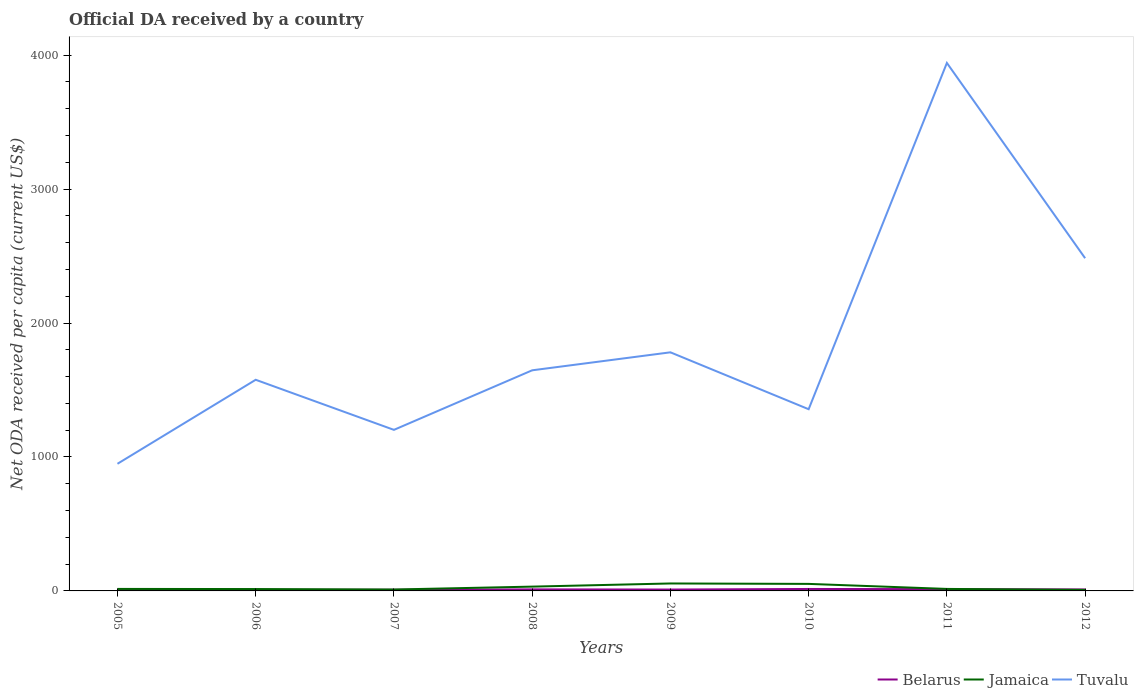How many different coloured lines are there?
Offer a very short reply. 3. Does the line corresponding to Tuvalu intersect with the line corresponding to Jamaica?
Give a very brief answer. No. Across all years, what is the maximum ODA received in in Belarus?
Your answer should be very brief. 5.98. In which year was the ODA received in in Jamaica maximum?
Your response must be concise. 2012. What is the total ODA received in in Belarus in the graph?
Ensure brevity in your answer.  -2.15. What is the difference between the highest and the second highest ODA received in in Belarus?
Provide a succinct answer. 8.57. How many years are there in the graph?
Your response must be concise. 8. What is the difference between two consecutive major ticks on the Y-axis?
Ensure brevity in your answer.  1000. Where does the legend appear in the graph?
Give a very brief answer. Bottom right. How many legend labels are there?
Offer a terse response. 3. What is the title of the graph?
Your answer should be compact. Official DA received by a country. Does "Isle of Man" appear as one of the legend labels in the graph?
Give a very brief answer. No. What is the label or title of the X-axis?
Provide a short and direct response. Years. What is the label or title of the Y-axis?
Offer a terse response. Net ODA received per capita (current US$). What is the Net ODA received per capita (current US$) in Belarus in 2005?
Keep it short and to the point. 5.98. What is the Net ODA received per capita (current US$) in Jamaica in 2005?
Your answer should be very brief. 14.98. What is the Net ODA received per capita (current US$) in Tuvalu in 2005?
Make the answer very short. 949.04. What is the Net ODA received per capita (current US$) in Belarus in 2006?
Your answer should be very brief. 7.97. What is the Net ODA received per capita (current US$) of Jamaica in 2006?
Your answer should be very brief. 14.02. What is the Net ODA received per capita (current US$) of Tuvalu in 2006?
Ensure brevity in your answer.  1576.24. What is the Net ODA received per capita (current US$) of Belarus in 2007?
Provide a short and direct response. 8.76. What is the Net ODA received per capita (current US$) in Jamaica in 2007?
Make the answer very short. 10.55. What is the Net ODA received per capita (current US$) in Tuvalu in 2007?
Your answer should be compact. 1202.38. What is the Net ODA received per capita (current US$) of Belarus in 2008?
Give a very brief answer. 11.59. What is the Net ODA received per capita (current US$) in Jamaica in 2008?
Your answer should be compact. 32.12. What is the Net ODA received per capita (current US$) of Tuvalu in 2008?
Provide a short and direct response. 1646.91. What is the Net ODA received per capita (current US$) in Belarus in 2009?
Your answer should be compact. 10.27. What is the Net ODA received per capita (current US$) in Jamaica in 2009?
Offer a very short reply. 55.68. What is the Net ODA received per capita (current US$) in Tuvalu in 2009?
Your response must be concise. 1781.2. What is the Net ODA received per capita (current US$) in Belarus in 2010?
Ensure brevity in your answer.  14.55. What is the Net ODA received per capita (current US$) of Jamaica in 2010?
Provide a short and direct response. 52.49. What is the Net ODA received per capita (current US$) in Tuvalu in 2010?
Give a very brief answer. 1356.47. What is the Net ODA received per capita (current US$) of Belarus in 2011?
Provide a succinct answer. 13.3. What is the Net ODA received per capita (current US$) in Jamaica in 2011?
Your response must be concise. 14.91. What is the Net ODA received per capita (current US$) of Tuvalu in 2011?
Keep it short and to the point. 3941.49. What is the Net ODA received per capita (current US$) in Belarus in 2012?
Your answer should be compact. 10.91. What is the Net ODA received per capita (current US$) of Jamaica in 2012?
Keep it short and to the point. 7.77. What is the Net ODA received per capita (current US$) in Tuvalu in 2012?
Give a very brief answer. 2483.77. Across all years, what is the maximum Net ODA received per capita (current US$) in Belarus?
Your answer should be compact. 14.55. Across all years, what is the maximum Net ODA received per capita (current US$) in Jamaica?
Your response must be concise. 55.68. Across all years, what is the maximum Net ODA received per capita (current US$) of Tuvalu?
Give a very brief answer. 3941.49. Across all years, what is the minimum Net ODA received per capita (current US$) in Belarus?
Give a very brief answer. 5.98. Across all years, what is the minimum Net ODA received per capita (current US$) of Jamaica?
Offer a very short reply. 7.77. Across all years, what is the minimum Net ODA received per capita (current US$) in Tuvalu?
Keep it short and to the point. 949.04. What is the total Net ODA received per capita (current US$) of Belarus in the graph?
Keep it short and to the point. 83.34. What is the total Net ODA received per capita (current US$) of Jamaica in the graph?
Ensure brevity in your answer.  202.5. What is the total Net ODA received per capita (current US$) in Tuvalu in the graph?
Give a very brief answer. 1.49e+04. What is the difference between the Net ODA received per capita (current US$) in Belarus in 2005 and that in 2006?
Keep it short and to the point. -1.98. What is the difference between the Net ODA received per capita (current US$) in Jamaica in 2005 and that in 2006?
Provide a short and direct response. 0.96. What is the difference between the Net ODA received per capita (current US$) of Tuvalu in 2005 and that in 2006?
Keep it short and to the point. -627.2. What is the difference between the Net ODA received per capita (current US$) in Belarus in 2005 and that in 2007?
Your answer should be very brief. -2.78. What is the difference between the Net ODA received per capita (current US$) of Jamaica in 2005 and that in 2007?
Your answer should be compact. 4.43. What is the difference between the Net ODA received per capita (current US$) of Tuvalu in 2005 and that in 2007?
Your response must be concise. -253.34. What is the difference between the Net ODA received per capita (current US$) of Belarus in 2005 and that in 2008?
Provide a short and direct response. -5.61. What is the difference between the Net ODA received per capita (current US$) in Jamaica in 2005 and that in 2008?
Offer a very short reply. -17.14. What is the difference between the Net ODA received per capita (current US$) of Tuvalu in 2005 and that in 2008?
Ensure brevity in your answer.  -697.87. What is the difference between the Net ODA received per capita (current US$) of Belarus in 2005 and that in 2009?
Offer a very short reply. -4.29. What is the difference between the Net ODA received per capita (current US$) in Jamaica in 2005 and that in 2009?
Your answer should be very brief. -40.7. What is the difference between the Net ODA received per capita (current US$) in Tuvalu in 2005 and that in 2009?
Make the answer very short. -832.16. What is the difference between the Net ODA received per capita (current US$) in Belarus in 2005 and that in 2010?
Keep it short and to the point. -8.57. What is the difference between the Net ODA received per capita (current US$) in Jamaica in 2005 and that in 2010?
Offer a terse response. -37.51. What is the difference between the Net ODA received per capita (current US$) in Tuvalu in 2005 and that in 2010?
Ensure brevity in your answer.  -407.43. What is the difference between the Net ODA received per capita (current US$) in Belarus in 2005 and that in 2011?
Offer a very short reply. -7.32. What is the difference between the Net ODA received per capita (current US$) of Jamaica in 2005 and that in 2011?
Your response must be concise. 0.07. What is the difference between the Net ODA received per capita (current US$) of Tuvalu in 2005 and that in 2011?
Make the answer very short. -2992.45. What is the difference between the Net ODA received per capita (current US$) of Belarus in 2005 and that in 2012?
Provide a succinct answer. -4.93. What is the difference between the Net ODA received per capita (current US$) of Jamaica in 2005 and that in 2012?
Make the answer very short. 7.2. What is the difference between the Net ODA received per capita (current US$) in Tuvalu in 2005 and that in 2012?
Offer a very short reply. -1534.73. What is the difference between the Net ODA received per capita (current US$) in Belarus in 2006 and that in 2007?
Make the answer very short. -0.79. What is the difference between the Net ODA received per capita (current US$) in Jamaica in 2006 and that in 2007?
Your answer should be compact. 3.47. What is the difference between the Net ODA received per capita (current US$) of Tuvalu in 2006 and that in 2007?
Ensure brevity in your answer.  373.87. What is the difference between the Net ODA received per capita (current US$) in Belarus in 2006 and that in 2008?
Provide a short and direct response. -3.62. What is the difference between the Net ODA received per capita (current US$) in Jamaica in 2006 and that in 2008?
Keep it short and to the point. -18.1. What is the difference between the Net ODA received per capita (current US$) of Tuvalu in 2006 and that in 2008?
Make the answer very short. -70.67. What is the difference between the Net ODA received per capita (current US$) of Belarus in 2006 and that in 2009?
Your response must be concise. -2.3. What is the difference between the Net ODA received per capita (current US$) in Jamaica in 2006 and that in 2009?
Offer a terse response. -41.66. What is the difference between the Net ODA received per capita (current US$) of Tuvalu in 2006 and that in 2009?
Your answer should be compact. -204.96. What is the difference between the Net ODA received per capita (current US$) of Belarus in 2006 and that in 2010?
Give a very brief answer. -6.59. What is the difference between the Net ODA received per capita (current US$) of Jamaica in 2006 and that in 2010?
Offer a very short reply. -38.47. What is the difference between the Net ODA received per capita (current US$) in Tuvalu in 2006 and that in 2010?
Give a very brief answer. 219.78. What is the difference between the Net ODA received per capita (current US$) of Belarus in 2006 and that in 2011?
Keep it short and to the point. -5.33. What is the difference between the Net ODA received per capita (current US$) in Jamaica in 2006 and that in 2011?
Offer a terse response. -0.89. What is the difference between the Net ODA received per capita (current US$) in Tuvalu in 2006 and that in 2011?
Provide a short and direct response. -2365.24. What is the difference between the Net ODA received per capita (current US$) in Belarus in 2006 and that in 2012?
Give a very brief answer. -2.94. What is the difference between the Net ODA received per capita (current US$) in Jamaica in 2006 and that in 2012?
Provide a short and direct response. 6.24. What is the difference between the Net ODA received per capita (current US$) in Tuvalu in 2006 and that in 2012?
Provide a succinct answer. -907.53. What is the difference between the Net ODA received per capita (current US$) of Belarus in 2007 and that in 2008?
Ensure brevity in your answer.  -2.83. What is the difference between the Net ODA received per capita (current US$) of Jamaica in 2007 and that in 2008?
Offer a terse response. -21.57. What is the difference between the Net ODA received per capita (current US$) of Tuvalu in 2007 and that in 2008?
Provide a short and direct response. -444.54. What is the difference between the Net ODA received per capita (current US$) in Belarus in 2007 and that in 2009?
Keep it short and to the point. -1.51. What is the difference between the Net ODA received per capita (current US$) in Jamaica in 2007 and that in 2009?
Your answer should be compact. -45.13. What is the difference between the Net ODA received per capita (current US$) in Tuvalu in 2007 and that in 2009?
Give a very brief answer. -578.82. What is the difference between the Net ODA received per capita (current US$) in Belarus in 2007 and that in 2010?
Ensure brevity in your answer.  -5.79. What is the difference between the Net ODA received per capita (current US$) of Jamaica in 2007 and that in 2010?
Ensure brevity in your answer.  -41.94. What is the difference between the Net ODA received per capita (current US$) in Tuvalu in 2007 and that in 2010?
Your answer should be very brief. -154.09. What is the difference between the Net ODA received per capita (current US$) of Belarus in 2007 and that in 2011?
Your response must be concise. -4.54. What is the difference between the Net ODA received per capita (current US$) in Jamaica in 2007 and that in 2011?
Give a very brief answer. -4.36. What is the difference between the Net ODA received per capita (current US$) in Tuvalu in 2007 and that in 2011?
Provide a succinct answer. -2739.11. What is the difference between the Net ODA received per capita (current US$) in Belarus in 2007 and that in 2012?
Make the answer very short. -2.15. What is the difference between the Net ODA received per capita (current US$) of Jamaica in 2007 and that in 2012?
Your answer should be very brief. 2.77. What is the difference between the Net ODA received per capita (current US$) in Tuvalu in 2007 and that in 2012?
Your answer should be very brief. -1281.4. What is the difference between the Net ODA received per capita (current US$) of Belarus in 2008 and that in 2009?
Your answer should be compact. 1.32. What is the difference between the Net ODA received per capita (current US$) of Jamaica in 2008 and that in 2009?
Your response must be concise. -23.56. What is the difference between the Net ODA received per capita (current US$) of Tuvalu in 2008 and that in 2009?
Your answer should be very brief. -134.28. What is the difference between the Net ODA received per capita (current US$) in Belarus in 2008 and that in 2010?
Provide a succinct answer. -2.96. What is the difference between the Net ODA received per capita (current US$) in Jamaica in 2008 and that in 2010?
Make the answer very short. -20.37. What is the difference between the Net ODA received per capita (current US$) in Tuvalu in 2008 and that in 2010?
Your response must be concise. 290.45. What is the difference between the Net ODA received per capita (current US$) of Belarus in 2008 and that in 2011?
Give a very brief answer. -1.71. What is the difference between the Net ODA received per capita (current US$) of Jamaica in 2008 and that in 2011?
Make the answer very short. 17.21. What is the difference between the Net ODA received per capita (current US$) of Tuvalu in 2008 and that in 2011?
Provide a short and direct response. -2294.57. What is the difference between the Net ODA received per capita (current US$) in Belarus in 2008 and that in 2012?
Your answer should be very brief. 0.68. What is the difference between the Net ODA received per capita (current US$) of Jamaica in 2008 and that in 2012?
Your answer should be very brief. 24.34. What is the difference between the Net ODA received per capita (current US$) in Tuvalu in 2008 and that in 2012?
Give a very brief answer. -836.86. What is the difference between the Net ODA received per capita (current US$) in Belarus in 2009 and that in 2010?
Your answer should be compact. -4.28. What is the difference between the Net ODA received per capita (current US$) in Jamaica in 2009 and that in 2010?
Provide a succinct answer. 3.19. What is the difference between the Net ODA received per capita (current US$) of Tuvalu in 2009 and that in 2010?
Offer a terse response. 424.73. What is the difference between the Net ODA received per capita (current US$) of Belarus in 2009 and that in 2011?
Ensure brevity in your answer.  -3.03. What is the difference between the Net ODA received per capita (current US$) of Jamaica in 2009 and that in 2011?
Keep it short and to the point. 40.77. What is the difference between the Net ODA received per capita (current US$) of Tuvalu in 2009 and that in 2011?
Your response must be concise. -2160.29. What is the difference between the Net ODA received per capita (current US$) in Belarus in 2009 and that in 2012?
Offer a very short reply. -0.64. What is the difference between the Net ODA received per capita (current US$) in Jamaica in 2009 and that in 2012?
Provide a succinct answer. 47.91. What is the difference between the Net ODA received per capita (current US$) in Tuvalu in 2009 and that in 2012?
Provide a short and direct response. -702.57. What is the difference between the Net ODA received per capita (current US$) of Belarus in 2010 and that in 2011?
Your response must be concise. 1.25. What is the difference between the Net ODA received per capita (current US$) in Jamaica in 2010 and that in 2011?
Keep it short and to the point. 37.58. What is the difference between the Net ODA received per capita (current US$) in Tuvalu in 2010 and that in 2011?
Your answer should be very brief. -2585.02. What is the difference between the Net ODA received per capita (current US$) of Belarus in 2010 and that in 2012?
Ensure brevity in your answer.  3.64. What is the difference between the Net ODA received per capita (current US$) of Jamaica in 2010 and that in 2012?
Offer a very short reply. 44.71. What is the difference between the Net ODA received per capita (current US$) in Tuvalu in 2010 and that in 2012?
Make the answer very short. -1127.31. What is the difference between the Net ODA received per capita (current US$) of Belarus in 2011 and that in 2012?
Provide a short and direct response. 2.39. What is the difference between the Net ODA received per capita (current US$) of Jamaica in 2011 and that in 2012?
Offer a terse response. 7.13. What is the difference between the Net ODA received per capita (current US$) of Tuvalu in 2011 and that in 2012?
Offer a terse response. 1457.71. What is the difference between the Net ODA received per capita (current US$) in Belarus in 2005 and the Net ODA received per capita (current US$) in Jamaica in 2006?
Your response must be concise. -8.04. What is the difference between the Net ODA received per capita (current US$) in Belarus in 2005 and the Net ODA received per capita (current US$) in Tuvalu in 2006?
Keep it short and to the point. -1570.26. What is the difference between the Net ODA received per capita (current US$) in Jamaica in 2005 and the Net ODA received per capita (current US$) in Tuvalu in 2006?
Give a very brief answer. -1561.27. What is the difference between the Net ODA received per capita (current US$) in Belarus in 2005 and the Net ODA received per capita (current US$) in Jamaica in 2007?
Offer a terse response. -4.56. What is the difference between the Net ODA received per capita (current US$) of Belarus in 2005 and the Net ODA received per capita (current US$) of Tuvalu in 2007?
Offer a very short reply. -1196.39. What is the difference between the Net ODA received per capita (current US$) of Jamaica in 2005 and the Net ODA received per capita (current US$) of Tuvalu in 2007?
Offer a terse response. -1187.4. What is the difference between the Net ODA received per capita (current US$) in Belarus in 2005 and the Net ODA received per capita (current US$) in Jamaica in 2008?
Your response must be concise. -26.13. What is the difference between the Net ODA received per capita (current US$) of Belarus in 2005 and the Net ODA received per capita (current US$) of Tuvalu in 2008?
Keep it short and to the point. -1640.93. What is the difference between the Net ODA received per capita (current US$) of Jamaica in 2005 and the Net ODA received per capita (current US$) of Tuvalu in 2008?
Provide a short and direct response. -1631.94. What is the difference between the Net ODA received per capita (current US$) in Belarus in 2005 and the Net ODA received per capita (current US$) in Jamaica in 2009?
Give a very brief answer. -49.7. What is the difference between the Net ODA received per capita (current US$) of Belarus in 2005 and the Net ODA received per capita (current US$) of Tuvalu in 2009?
Give a very brief answer. -1775.22. What is the difference between the Net ODA received per capita (current US$) of Jamaica in 2005 and the Net ODA received per capita (current US$) of Tuvalu in 2009?
Your answer should be compact. -1766.22. What is the difference between the Net ODA received per capita (current US$) in Belarus in 2005 and the Net ODA received per capita (current US$) in Jamaica in 2010?
Your response must be concise. -46.5. What is the difference between the Net ODA received per capita (current US$) of Belarus in 2005 and the Net ODA received per capita (current US$) of Tuvalu in 2010?
Ensure brevity in your answer.  -1350.48. What is the difference between the Net ODA received per capita (current US$) in Jamaica in 2005 and the Net ODA received per capita (current US$) in Tuvalu in 2010?
Your answer should be very brief. -1341.49. What is the difference between the Net ODA received per capita (current US$) of Belarus in 2005 and the Net ODA received per capita (current US$) of Jamaica in 2011?
Make the answer very short. -8.93. What is the difference between the Net ODA received per capita (current US$) in Belarus in 2005 and the Net ODA received per capita (current US$) in Tuvalu in 2011?
Your answer should be compact. -3935.5. What is the difference between the Net ODA received per capita (current US$) of Jamaica in 2005 and the Net ODA received per capita (current US$) of Tuvalu in 2011?
Your response must be concise. -3926.51. What is the difference between the Net ODA received per capita (current US$) of Belarus in 2005 and the Net ODA received per capita (current US$) of Jamaica in 2012?
Make the answer very short. -1.79. What is the difference between the Net ODA received per capita (current US$) in Belarus in 2005 and the Net ODA received per capita (current US$) in Tuvalu in 2012?
Keep it short and to the point. -2477.79. What is the difference between the Net ODA received per capita (current US$) of Jamaica in 2005 and the Net ODA received per capita (current US$) of Tuvalu in 2012?
Offer a terse response. -2468.8. What is the difference between the Net ODA received per capita (current US$) of Belarus in 2006 and the Net ODA received per capita (current US$) of Jamaica in 2007?
Give a very brief answer. -2.58. What is the difference between the Net ODA received per capita (current US$) of Belarus in 2006 and the Net ODA received per capita (current US$) of Tuvalu in 2007?
Provide a succinct answer. -1194.41. What is the difference between the Net ODA received per capita (current US$) in Jamaica in 2006 and the Net ODA received per capita (current US$) in Tuvalu in 2007?
Offer a very short reply. -1188.36. What is the difference between the Net ODA received per capita (current US$) of Belarus in 2006 and the Net ODA received per capita (current US$) of Jamaica in 2008?
Make the answer very short. -24.15. What is the difference between the Net ODA received per capita (current US$) of Belarus in 2006 and the Net ODA received per capita (current US$) of Tuvalu in 2008?
Ensure brevity in your answer.  -1638.95. What is the difference between the Net ODA received per capita (current US$) in Jamaica in 2006 and the Net ODA received per capita (current US$) in Tuvalu in 2008?
Make the answer very short. -1632.9. What is the difference between the Net ODA received per capita (current US$) of Belarus in 2006 and the Net ODA received per capita (current US$) of Jamaica in 2009?
Your response must be concise. -47.71. What is the difference between the Net ODA received per capita (current US$) of Belarus in 2006 and the Net ODA received per capita (current US$) of Tuvalu in 2009?
Provide a short and direct response. -1773.23. What is the difference between the Net ODA received per capita (current US$) in Jamaica in 2006 and the Net ODA received per capita (current US$) in Tuvalu in 2009?
Offer a very short reply. -1767.18. What is the difference between the Net ODA received per capita (current US$) of Belarus in 2006 and the Net ODA received per capita (current US$) of Jamaica in 2010?
Your answer should be compact. -44.52. What is the difference between the Net ODA received per capita (current US$) in Belarus in 2006 and the Net ODA received per capita (current US$) in Tuvalu in 2010?
Your answer should be very brief. -1348.5. What is the difference between the Net ODA received per capita (current US$) of Jamaica in 2006 and the Net ODA received per capita (current US$) of Tuvalu in 2010?
Keep it short and to the point. -1342.45. What is the difference between the Net ODA received per capita (current US$) of Belarus in 2006 and the Net ODA received per capita (current US$) of Jamaica in 2011?
Give a very brief answer. -6.94. What is the difference between the Net ODA received per capita (current US$) in Belarus in 2006 and the Net ODA received per capita (current US$) in Tuvalu in 2011?
Provide a short and direct response. -3933.52. What is the difference between the Net ODA received per capita (current US$) of Jamaica in 2006 and the Net ODA received per capita (current US$) of Tuvalu in 2011?
Offer a very short reply. -3927.47. What is the difference between the Net ODA received per capita (current US$) in Belarus in 2006 and the Net ODA received per capita (current US$) in Jamaica in 2012?
Make the answer very short. 0.19. What is the difference between the Net ODA received per capita (current US$) of Belarus in 2006 and the Net ODA received per capita (current US$) of Tuvalu in 2012?
Give a very brief answer. -2475.81. What is the difference between the Net ODA received per capita (current US$) of Jamaica in 2006 and the Net ODA received per capita (current US$) of Tuvalu in 2012?
Provide a succinct answer. -2469.75. What is the difference between the Net ODA received per capita (current US$) of Belarus in 2007 and the Net ODA received per capita (current US$) of Jamaica in 2008?
Ensure brevity in your answer.  -23.35. What is the difference between the Net ODA received per capita (current US$) in Belarus in 2007 and the Net ODA received per capita (current US$) in Tuvalu in 2008?
Offer a very short reply. -1638.15. What is the difference between the Net ODA received per capita (current US$) in Jamaica in 2007 and the Net ODA received per capita (current US$) in Tuvalu in 2008?
Keep it short and to the point. -1636.37. What is the difference between the Net ODA received per capita (current US$) of Belarus in 2007 and the Net ODA received per capita (current US$) of Jamaica in 2009?
Your answer should be very brief. -46.92. What is the difference between the Net ODA received per capita (current US$) in Belarus in 2007 and the Net ODA received per capita (current US$) in Tuvalu in 2009?
Give a very brief answer. -1772.44. What is the difference between the Net ODA received per capita (current US$) of Jamaica in 2007 and the Net ODA received per capita (current US$) of Tuvalu in 2009?
Offer a very short reply. -1770.65. What is the difference between the Net ODA received per capita (current US$) of Belarus in 2007 and the Net ODA received per capita (current US$) of Jamaica in 2010?
Offer a terse response. -43.72. What is the difference between the Net ODA received per capita (current US$) in Belarus in 2007 and the Net ODA received per capita (current US$) in Tuvalu in 2010?
Keep it short and to the point. -1347.71. What is the difference between the Net ODA received per capita (current US$) of Jamaica in 2007 and the Net ODA received per capita (current US$) of Tuvalu in 2010?
Provide a short and direct response. -1345.92. What is the difference between the Net ODA received per capita (current US$) in Belarus in 2007 and the Net ODA received per capita (current US$) in Jamaica in 2011?
Offer a terse response. -6.15. What is the difference between the Net ODA received per capita (current US$) of Belarus in 2007 and the Net ODA received per capita (current US$) of Tuvalu in 2011?
Give a very brief answer. -3932.73. What is the difference between the Net ODA received per capita (current US$) of Jamaica in 2007 and the Net ODA received per capita (current US$) of Tuvalu in 2011?
Ensure brevity in your answer.  -3930.94. What is the difference between the Net ODA received per capita (current US$) of Belarus in 2007 and the Net ODA received per capita (current US$) of Jamaica in 2012?
Keep it short and to the point. 0.99. What is the difference between the Net ODA received per capita (current US$) in Belarus in 2007 and the Net ODA received per capita (current US$) in Tuvalu in 2012?
Your answer should be compact. -2475.01. What is the difference between the Net ODA received per capita (current US$) in Jamaica in 2007 and the Net ODA received per capita (current US$) in Tuvalu in 2012?
Your answer should be very brief. -2473.23. What is the difference between the Net ODA received per capita (current US$) of Belarus in 2008 and the Net ODA received per capita (current US$) of Jamaica in 2009?
Provide a succinct answer. -44.09. What is the difference between the Net ODA received per capita (current US$) in Belarus in 2008 and the Net ODA received per capita (current US$) in Tuvalu in 2009?
Your answer should be very brief. -1769.61. What is the difference between the Net ODA received per capita (current US$) of Jamaica in 2008 and the Net ODA received per capita (current US$) of Tuvalu in 2009?
Provide a succinct answer. -1749.08. What is the difference between the Net ODA received per capita (current US$) of Belarus in 2008 and the Net ODA received per capita (current US$) of Jamaica in 2010?
Offer a very short reply. -40.9. What is the difference between the Net ODA received per capita (current US$) in Belarus in 2008 and the Net ODA received per capita (current US$) in Tuvalu in 2010?
Ensure brevity in your answer.  -1344.88. What is the difference between the Net ODA received per capita (current US$) in Jamaica in 2008 and the Net ODA received per capita (current US$) in Tuvalu in 2010?
Your answer should be compact. -1324.35. What is the difference between the Net ODA received per capita (current US$) of Belarus in 2008 and the Net ODA received per capita (current US$) of Jamaica in 2011?
Your answer should be very brief. -3.32. What is the difference between the Net ODA received per capita (current US$) of Belarus in 2008 and the Net ODA received per capita (current US$) of Tuvalu in 2011?
Your answer should be very brief. -3929.9. What is the difference between the Net ODA received per capita (current US$) of Jamaica in 2008 and the Net ODA received per capita (current US$) of Tuvalu in 2011?
Keep it short and to the point. -3909.37. What is the difference between the Net ODA received per capita (current US$) of Belarus in 2008 and the Net ODA received per capita (current US$) of Jamaica in 2012?
Give a very brief answer. 3.82. What is the difference between the Net ODA received per capita (current US$) in Belarus in 2008 and the Net ODA received per capita (current US$) in Tuvalu in 2012?
Make the answer very short. -2472.18. What is the difference between the Net ODA received per capita (current US$) in Jamaica in 2008 and the Net ODA received per capita (current US$) in Tuvalu in 2012?
Give a very brief answer. -2451.66. What is the difference between the Net ODA received per capita (current US$) in Belarus in 2009 and the Net ODA received per capita (current US$) in Jamaica in 2010?
Offer a very short reply. -42.21. What is the difference between the Net ODA received per capita (current US$) of Belarus in 2009 and the Net ODA received per capita (current US$) of Tuvalu in 2010?
Make the answer very short. -1346.19. What is the difference between the Net ODA received per capita (current US$) in Jamaica in 2009 and the Net ODA received per capita (current US$) in Tuvalu in 2010?
Offer a very short reply. -1300.79. What is the difference between the Net ODA received per capita (current US$) in Belarus in 2009 and the Net ODA received per capita (current US$) in Jamaica in 2011?
Give a very brief answer. -4.64. What is the difference between the Net ODA received per capita (current US$) of Belarus in 2009 and the Net ODA received per capita (current US$) of Tuvalu in 2011?
Keep it short and to the point. -3931.21. What is the difference between the Net ODA received per capita (current US$) of Jamaica in 2009 and the Net ODA received per capita (current US$) of Tuvalu in 2011?
Your response must be concise. -3885.81. What is the difference between the Net ODA received per capita (current US$) of Belarus in 2009 and the Net ODA received per capita (current US$) of Jamaica in 2012?
Provide a succinct answer. 2.5. What is the difference between the Net ODA received per capita (current US$) in Belarus in 2009 and the Net ODA received per capita (current US$) in Tuvalu in 2012?
Keep it short and to the point. -2473.5. What is the difference between the Net ODA received per capita (current US$) in Jamaica in 2009 and the Net ODA received per capita (current US$) in Tuvalu in 2012?
Ensure brevity in your answer.  -2428.09. What is the difference between the Net ODA received per capita (current US$) in Belarus in 2010 and the Net ODA received per capita (current US$) in Jamaica in 2011?
Your answer should be very brief. -0.36. What is the difference between the Net ODA received per capita (current US$) of Belarus in 2010 and the Net ODA received per capita (current US$) of Tuvalu in 2011?
Your answer should be very brief. -3926.93. What is the difference between the Net ODA received per capita (current US$) of Jamaica in 2010 and the Net ODA received per capita (current US$) of Tuvalu in 2011?
Provide a succinct answer. -3889. What is the difference between the Net ODA received per capita (current US$) in Belarus in 2010 and the Net ODA received per capita (current US$) in Jamaica in 2012?
Give a very brief answer. 6.78. What is the difference between the Net ODA received per capita (current US$) in Belarus in 2010 and the Net ODA received per capita (current US$) in Tuvalu in 2012?
Offer a terse response. -2469.22. What is the difference between the Net ODA received per capita (current US$) of Jamaica in 2010 and the Net ODA received per capita (current US$) of Tuvalu in 2012?
Your answer should be very brief. -2431.29. What is the difference between the Net ODA received per capita (current US$) in Belarus in 2011 and the Net ODA received per capita (current US$) in Jamaica in 2012?
Your answer should be compact. 5.53. What is the difference between the Net ODA received per capita (current US$) of Belarus in 2011 and the Net ODA received per capita (current US$) of Tuvalu in 2012?
Offer a terse response. -2470.47. What is the difference between the Net ODA received per capita (current US$) of Jamaica in 2011 and the Net ODA received per capita (current US$) of Tuvalu in 2012?
Offer a terse response. -2468.86. What is the average Net ODA received per capita (current US$) in Belarus per year?
Your response must be concise. 10.42. What is the average Net ODA received per capita (current US$) in Jamaica per year?
Your answer should be very brief. 25.31. What is the average Net ODA received per capita (current US$) of Tuvalu per year?
Provide a short and direct response. 1867.19. In the year 2005, what is the difference between the Net ODA received per capita (current US$) of Belarus and Net ODA received per capita (current US$) of Jamaica?
Provide a succinct answer. -8.99. In the year 2005, what is the difference between the Net ODA received per capita (current US$) in Belarus and Net ODA received per capita (current US$) in Tuvalu?
Provide a succinct answer. -943.06. In the year 2005, what is the difference between the Net ODA received per capita (current US$) in Jamaica and Net ODA received per capita (current US$) in Tuvalu?
Your response must be concise. -934.06. In the year 2006, what is the difference between the Net ODA received per capita (current US$) of Belarus and Net ODA received per capita (current US$) of Jamaica?
Give a very brief answer. -6.05. In the year 2006, what is the difference between the Net ODA received per capita (current US$) in Belarus and Net ODA received per capita (current US$) in Tuvalu?
Provide a succinct answer. -1568.28. In the year 2006, what is the difference between the Net ODA received per capita (current US$) in Jamaica and Net ODA received per capita (current US$) in Tuvalu?
Your response must be concise. -1562.23. In the year 2007, what is the difference between the Net ODA received per capita (current US$) of Belarus and Net ODA received per capita (current US$) of Jamaica?
Provide a short and direct response. -1.78. In the year 2007, what is the difference between the Net ODA received per capita (current US$) in Belarus and Net ODA received per capita (current US$) in Tuvalu?
Provide a succinct answer. -1193.61. In the year 2007, what is the difference between the Net ODA received per capita (current US$) of Jamaica and Net ODA received per capita (current US$) of Tuvalu?
Give a very brief answer. -1191.83. In the year 2008, what is the difference between the Net ODA received per capita (current US$) of Belarus and Net ODA received per capita (current US$) of Jamaica?
Provide a succinct answer. -20.53. In the year 2008, what is the difference between the Net ODA received per capita (current US$) of Belarus and Net ODA received per capita (current US$) of Tuvalu?
Keep it short and to the point. -1635.33. In the year 2008, what is the difference between the Net ODA received per capita (current US$) in Jamaica and Net ODA received per capita (current US$) in Tuvalu?
Your answer should be very brief. -1614.8. In the year 2009, what is the difference between the Net ODA received per capita (current US$) of Belarus and Net ODA received per capita (current US$) of Jamaica?
Keep it short and to the point. -45.41. In the year 2009, what is the difference between the Net ODA received per capita (current US$) of Belarus and Net ODA received per capita (current US$) of Tuvalu?
Provide a succinct answer. -1770.93. In the year 2009, what is the difference between the Net ODA received per capita (current US$) of Jamaica and Net ODA received per capita (current US$) of Tuvalu?
Your answer should be very brief. -1725.52. In the year 2010, what is the difference between the Net ODA received per capita (current US$) in Belarus and Net ODA received per capita (current US$) in Jamaica?
Your answer should be very brief. -37.93. In the year 2010, what is the difference between the Net ODA received per capita (current US$) of Belarus and Net ODA received per capita (current US$) of Tuvalu?
Ensure brevity in your answer.  -1341.91. In the year 2010, what is the difference between the Net ODA received per capita (current US$) in Jamaica and Net ODA received per capita (current US$) in Tuvalu?
Provide a short and direct response. -1303.98. In the year 2011, what is the difference between the Net ODA received per capita (current US$) of Belarus and Net ODA received per capita (current US$) of Jamaica?
Offer a very short reply. -1.61. In the year 2011, what is the difference between the Net ODA received per capita (current US$) in Belarus and Net ODA received per capita (current US$) in Tuvalu?
Keep it short and to the point. -3928.19. In the year 2011, what is the difference between the Net ODA received per capita (current US$) in Jamaica and Net ODA received per capita (current US$) in Tuvalu?
Keep it short and to the point. -3926.58. In the year 2012, what is the difference between the Net ODA received per capita (current US$) in Belarus and Net ODA received per capita (current US$) in Jamaica?
Provide a succinct answer. 3.14. In the year 2012, what is the difference between the Net ODA received per capita (current US$) of Belarus and Net ODA received per capita (current US$) of Tuvalu?
Your response must be concise. -2472.86. In the year 2012, what is the difference between the Net ODA received per capita (current US$) of Jamaica and Net ODA received per capita (current US$) of Tuvalu?
Offer a very short reply. -2476. What is the ratio of the Net ODA received per capita (current US$) in Belarus in 2005 to that in 2006?
Your answer should be compact. 0.75. What is the ratio of the Net ODA received per capita (current US$) in Jamaica in 2005 to that in 2006?
Offer a terse response. 1.07. What is the ratio of the Net ODA received per capita (current US$) in Tuvalu in 2005 to that in 2006?
Give a very brief answer. 0.6. What is the ratio of the Net ODA received per capita (current US$) in Belarus in 2005 to that in 2007?
Your answer should be compact. 0.68. What is the ratio of the Net ODA received per capita (current US$) of Jamaica in 2005 to that in 2007?
Offer a very short reply. 1.42. What is the ratio of the Net ODA received per capita (current US$) of Tuvalu in 2005 to that in 2007?
Keep it short and to the point. 0.79. What is the ratio of the Net ODA received per capita (current US$) in Belarus in 2005 to that in 2008?
Give a very brief answer. 0.52. What is the ratio of the Net ODA received per capita (current US$) in Jamaica in 2005 to that in 2008?
Offer a very short reply. 0.47. What is the ratio of the Net ODA received per capita (current US$) in Tuvalu in 2005 to that in 2008?
Keep it short and to the point. 0.58. What is the ratio of the Net ODA received per capita (current US$) in Belarus in 2005 to that in 2009?
Ensure brevity in your answer.  0.58. What is the ratio of the Net ODA received per capita (current US$) in Jamaica in 2005 to that in 2009?
Offer a very short reply. 0.27. What is the ratio of the Net ODA received per capita (current US$) of Tuvalu in 2005 to that in 2009?
Your answer should be compact. 0.53. What is the ratio of the Net ODA received per capita (current US$) of Belarus in 2005 to that in 2010?
Make the answer very short. 0.41. What is the ratio of the Net ODA received per capita (current US$) in Jamaica in 2005 to that in 2010?
Your answer should be compact. 0.29. What is the ratio of the Net ODA received per capita (current US$) in Tuvalu in 2005 to that in 2010?
Offer a terse response. 0.7. What is the ratio of the Net ODA received per capita (current US$) of Belarus in 2005 to that in 2011?
Make the answer very short. 0.45. What is the ratio of the Net ODA received per capita (current US$) in Jamaica in 2005 to that in 2011?
Your answer should be very brief. 1. What is the ratio of the Net ODA received per capita (current US$) in Tuvalu in 2005 to that in 2011?
Your response must be concise. 0.24. What is the ratio of the Net ODA received per capita (current US$) of Belarus in 2005 to that in 2012?
Provide a short and direct response. 0.55. What is the ratio of the Net ODA received per capita (current US$) in Jamaica in 2005 to that in 2012?
Offer a terse response. 1.93. What is the ratio of the Net ODA received per capita (current US$) of Tuvalu in 2005 to that in 2012?
Your response must be concise. 0.38. What is the ratio of the Net ODA received per capita (current US$) of Belarus in 2006 to that in 2007?
Offer a very short reply. 0.91. What is the ratio of the Net ODA received per capita (current US$) in Jamaica in 2006 to that in 2007?
Your response must be concise. 1.33. What is the ratio of the Net ODA received per capita (current US$) in Tuvalu in 2006 to that in 2007?
Ensure brevity in your answer.  1.31. What is the ratio of the Net ODA received per capita (current US$) in Belarus in 2006 to that in 2008?
Your response must be concise. 0.69. What is the ratio of the Net ODA received per capita (current US$) of Jamaica in 2006 to that in 2008?
Offer a terse response. 0.44. What is the ratio of the Net ODA received per capita (current US$) in Tuvalu in 2006 to that in 2008?
Ensure brevity in your answer.  0.96. What is the ratio of the Net ODA received per capita (current US$) of Belarus in 2006 to that in 2009?
Your answer should be compact. 0.78. What is the ratio of the Net ODA received per capita (current US$) in Jamaica in 2006 to that in 2009?
Offer a terse response. 0.25. What is the ratio of the Net ODA received per capita (current US$) of Tuvalu in 2006 to that in 2009?
Provide a short and direct response. 0.88. What is the ratio of the Net ODA received per capita (current US$) of Belarus in 2006 to that in 2010?
Your answer should be very brief. 0.55. What is the ratio of the Net ODA received per capita (current US$) in Jamaica in 2006 to that in 2010?
Ensure brevity in your answer.  0.27. What is the ratio of the Net ODA received per capita (current US$) of Tuvalu in 2006 to that in 2010?
Provide a short and direct response. 1.16. What is the ratio of the Net ODA received per capita (current US$) of Belarus in 2006 to that in 2011?
Keep it short and to the point. 0.6. What is the ratio of the Net ODA received per capita (current US$) of Jamaica in 2006 to that in 2011?
Provide a succinct answer. 0.94. What is the ratio of the Net ODA received per capita (current US$) in Tuvalu in 2006 to that in 2011?
Provide a short and direct response. 0.4. What is the ratio of the Net ODA received per capita (current US$) of Belarus in 2006 to that in 2012?
Give a very brief answer. 0.73. What is the ratio of the Net ODA received per capita (current US$) of Jamaica in 2006 to that in 2012?
Provide a short and direct response. 1.8. What is the ratio of the Net ODA received per capita (current US$) of Tuvalu in 2006 to that in 2012?
Your response must be concise. 0.63. What is the ratio of the Net ODA received per capita (current US$) in Belarus in 2007 to that in 2008?
Make the answer very short. 0.76. What is the ratio of the Net ODA received per capita (current US$) in Jamaica in 2007 to that in 2008?
Provide a short and direct response. 0.33. What is the ratio of the Net ODA received per capita (current US$) in Tuvalu in 2007 to that in 2008?
Provide a succinct answer. 0.73. What is the ratio of the Net ODA received per capita (current US$) of Belarus in 2007 to that in 2009?
Your response must be concise. 0.85. What is the ratio of the Net ODA received per capita (current US$) in Jamaica in 2007 to that in 2009?
Provide a short and direct response. 0.19. What is the ratio of the Net ODA received per capita (current US$) in Tuvalu in 2007 to that in 2009?
Make the answer very short. 0.68. What is the ratio of the Net ODA received per capita (current US$) in Belarus in 2007 to that in 2010?
Offer a terse response. 0.6. What is the ratio of the Net ODA received per capita (current US$) of Jamaica in 2007 to that in 2010?
Your answer should be very brief. 0.2. What is the ratio of the Net ODA received per capita (current US$) in Tuvalu in 2007 to that in 2010?
Make the answer very short. 0.89. What is the ratio of the Net ODA received per capita (current US$) of Belarus in 2007 to that in 2011?
Offer a terse response. 0.66. What is the ratio of the Net ODA received per capita (current US$) in Jamaica in 2007 to that in 2011?
Keep it short and to the point. 0.71. What is the ratio of the Net ODA received per capita (current US$) in Tuvalu in 2007 to that in 2011?
Offer a very short reply. 0.31. What is the ratio of the Net ODA received per capita (current US$) in Belarus in 2007 to that in 2012?
Your response must be concise. 0.8. What is the ratio of the Net ODA received per capita (current US$) of Jamaica in 2007 to that in 2012?
Make the answer very short. 1.36. What is the ratio of the Net ODA received per capita (current US$) of Tuvalu in 2007 to that in 2012?
Provide a succinct answer. 0.48. What is the ratio of the Net ODA received per capita (current US$) of Belarus in 2008 to that in 2009?
Your answer should be compact. 1.13. What is the ratio of the Net ODA received per capita (current US$) of Jamaica in 2008 to that in 2009?
Give a very brief answer. 0.58. What is the ratio of the Net ODA received per capita (current US$) in Tuvalu in 2008 to that in 2009?
Keep it short and to the point. 0.92. What is the ratio of the Net ODA received per capita (current US$) in Belarus in 2008 to that in 2010?
Provide a succinct answer. 0.8. What is the ratio of the Net ODA received per capita (current US$) in Jamaica in 2008 to that in 2010?
Ensure brevity in your answer.  0.61. What is the ratio of the Net ODA received per capita (current US$) in Tuvalu in 2008 to that in 2010?
Your answer should be very brief. 1.21. What is the ratio of the Net ODA received per capita (current US$) in Belarus in 2008 to that in 2011?
Offer a terse response. 0.87. What is the ratio of the Net ODA received per capita (current US$) in Jamaica in 2008 to that in 2011?
Your answer should be compact. 2.15. What is the ratio of the Net ODA received per capita (current US$) in Tuvalu in 2008 to that in 2011?
Provide a succinct answer. 0.42. What is the ratio of the Net ODA received per capita (current US$) in Belarus in 2008 to that in 2012?
Give a very brief answer. 1.06. What is the ratio of the Net ODA received per capita (current US$) of Jamaica in 2008 to that in 2012?
Your response must be concise. 4.13. What is the ratio of the Net ODA received per capita (current US$) of Tuvalu in 2008 to that in 2012?
Provide a succinct answer. 0.66. What is the ratio of the Net ODA received per capita (current US$) in Belarus in 2009 to that in 2010?
Ensure brevity in your answer.  0.71. What is the ratio of the Net ODA received per capita (current US$) of Jamaica in 2009 to that in 2010?
Your response must be concise. 1.06. What is the ratio of the Net ODA received per capita (current US$) of Tuvalu in 2009 to that in 2010?
Ensure brevity in your answer.  1.31. What is the ratio of the Net ODA received per capita (current US$) of Belarus in 2009 to that in 2011?
Provide a succinct answer. 0.77. What is the ratio of the Net ODA received per capita (current US$) of Jamaica in 2009 to that in 2011?
Your response must be concise. 3.73. What is the ratio of the Net ODA received per capita (current US$) of Tuvalu in 2009 to that in 2011?
Your answer should be very brief. 0.45. What is the ratio of the Net ODA received per capita (current US$) in Belarus in 2009 to that in 2012?
Provide a succinct answer. 0.94. What is the ratio of the Net ODA received per capita (current US$) in Jamaica in 2009 to that in 2012?
Give a very brief answer. 7.16. What is the ratio of the Net ODA received per capita (current US$) in Tuvalu in 2009 to that in 2012?
Your response must be concise. 0.72. What is the ratio of the Net ODA received per capita (current US$) in Belarus in 2010 to that in 2011?
Keep it short and to the point. 1.09. What is the ratio of the Net ODA received per capita (current US$) of Jamaica in 2010 to that in 2011?
Ensure brevity in your answer.  3.52. What is the ratio of the Net ODA received per capita (current US$) in Tuvalu in 2010 to that in 2011?
Your response must be concise. 0.34. What is the ratio of the Net ODA received per capita (current US$) of Belarus in 2010 to that in 2012?
Offer a terse response. 1.33. What is the ratio of the Net ODA received per capita (current US$) in Jamaica in 2010 to that in 2012?
Provide a succinct answer. 6.75. What is the ratio of the Net ODA received per capita (current US$) in Tuvalu in 2010 to that in 2012?
Ensure brevity in your answer.  0.55. What is the ratio of the Net ODA received per capita (current US$) in Belarus in 2011 to that in 2012?
Your answer should be very brief. 1.22. What is the ratio of the Net ODA received per capita (current US$) of Jamaica in 2011 to that in 2012?
Ensure brevity in your answer.  1.92. What is the ratio of the Net ODA received per capita (current US$) of Tuvalu in 2011 to that in 2012?
Your answer should be very brief. 1.59. What is the difference between the highest and the second highest Net ODA received per capita (current US$) of Belarus?
Ensure brevity in your answer.  1.25. What is the difference between the highest and the second highest Net ODA received per capita (current US$) of Jamaica?
Provide a succinct answer. 3.19. What is the difference between the highest and the second highest Net ODA received per capita (current US$) in Tuvalu?
Ensure brevity in your answer.  1457.71. What is the difference between the highest and the lowest Net ODA received per capita (current US$) in Belarus?
Your response must be concise. 8.57. What is the difference between the highest and the lowest Net ODA received per capita (current US$) of Jamaica?
Give a very brief answer. 47.91. What is the difference between the highest and the lowest Net ODA received per capita (current US$) in Tuvalu?
Your answer should be very brief. 2992.45. 